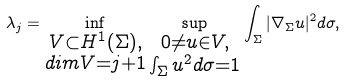<formula> <loc_0><loc_0><loc_500><loc_500>\lambda _ { j } = \inf _ { \substack { V \subset H ^ { 1 } ( \Sigma ) , \\ d i m V = j + 1 } } \sup _ { \substack { 0 \neq u \in V , \\ \int _ { \Sigma } u ^ { 2 } d \sigma = 1 } } \int _ { \Sigma } | \nabla _ { \Sigma } u | ^ { 2 } d \sigma ,</formula> 